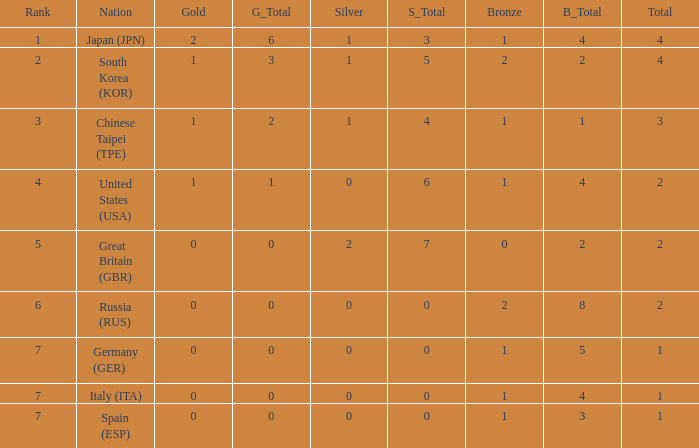How many total medals does a country with more than 1 silver medals have? 2.0. Would you mind parsing the complete table? {'header': ['Rank', 'Nation', 'Gold', 'G_Total', 'Silver', 'S_Total', 'Bronze', 'B_Total', 'Total'], 'rows': [['1', 'Japan (JPN)', '2', '6', '1', '3', '1', '4', '4'], ['2', 'South Korea (KOR)', '1', '3', '1', '5', '2', '2', '4'], ['3', 'Chinese Taipei (TPE)', '1', '2', '1', '4', '1', '1', '3'], ['4', 'United States (USA)', '1', '1', '0', '6', '1', '4', '2'], ['5', 'Great Britain (GBR)', '0', '0', '2', '7', '0', '2', '2'], ['6', 'Russia (RUS)', '0', '0', '0', '0', '2', '8', '2'], ['7', 'Germany (GER)', '0', '0', '0', '0', '1', '5', '1'], ['7', 'Italy (ITA)', '0', '0', '0', '0', '1', '4', '1'], ['7', 'Spain (ESP)', '0', '0', '0', '0', '1', '3', '1']]} 